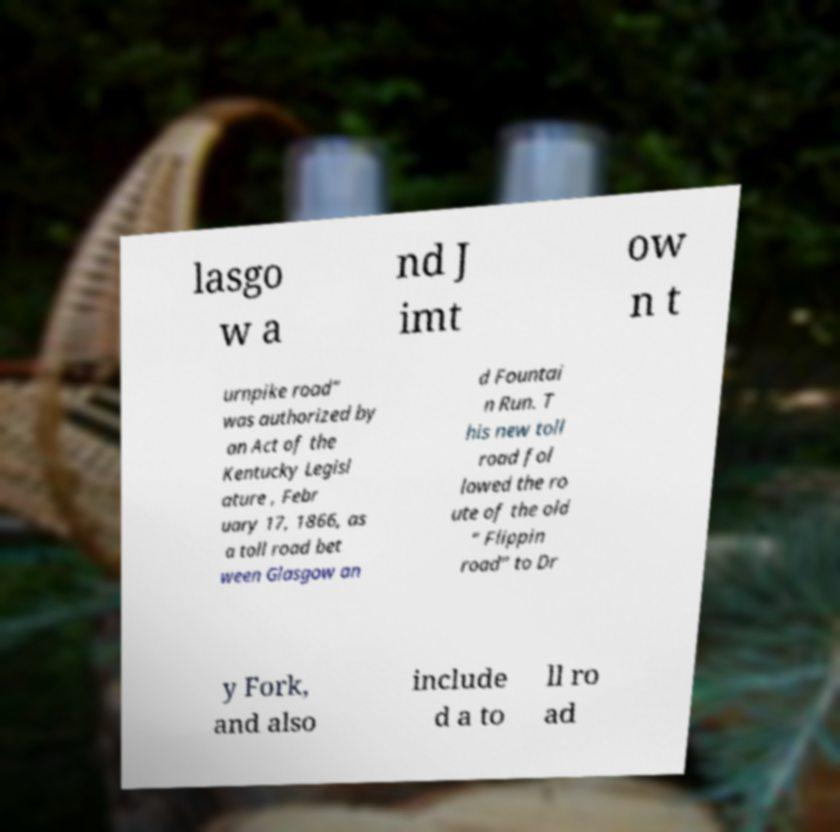What messages or text are displayed in this image? I need them in a readable, typed format. lasgo w a nd J imt ow n t urnpike road” was authorized by an Act of the Kentucky Legisl ature , Febr uary 17, 1866, as a toll road bet ween Glasgow an d Fountai n Run. T his new toll road fol lowed the ro ute of the old “ Flippin road” to Dr y Fork, and also include d a to ll ro ad 